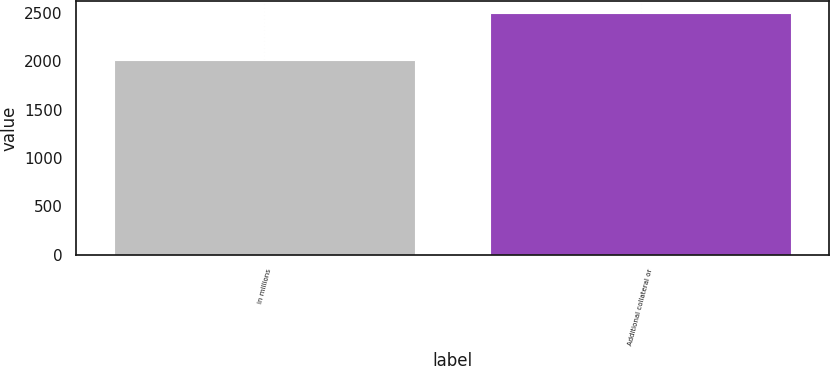Convert chart to OTSL. <chart><loc_0><loc_0><loc_500><loc_500><bar_chart><fcel>in millions<fcel>Additional collateral or<nl><fcel>2012<fcel>2500<nl></chart> 